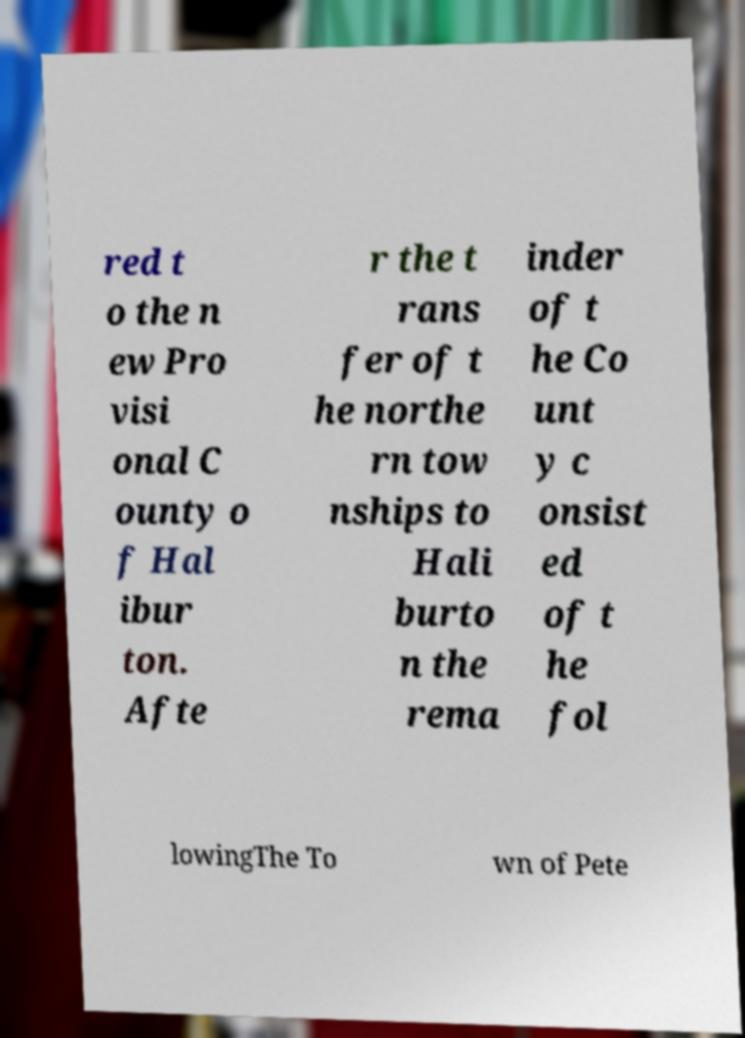Could you extract and type out the text from this image? red t o the n ew Pro visi onal C ounty o f Hal ibur ton. Afte r the t rans fer of t he northe rn tow nships to Hali burto n the rema inder of t he Co unt y c onsist ed of t he fol lowingThe To wn of Pete 